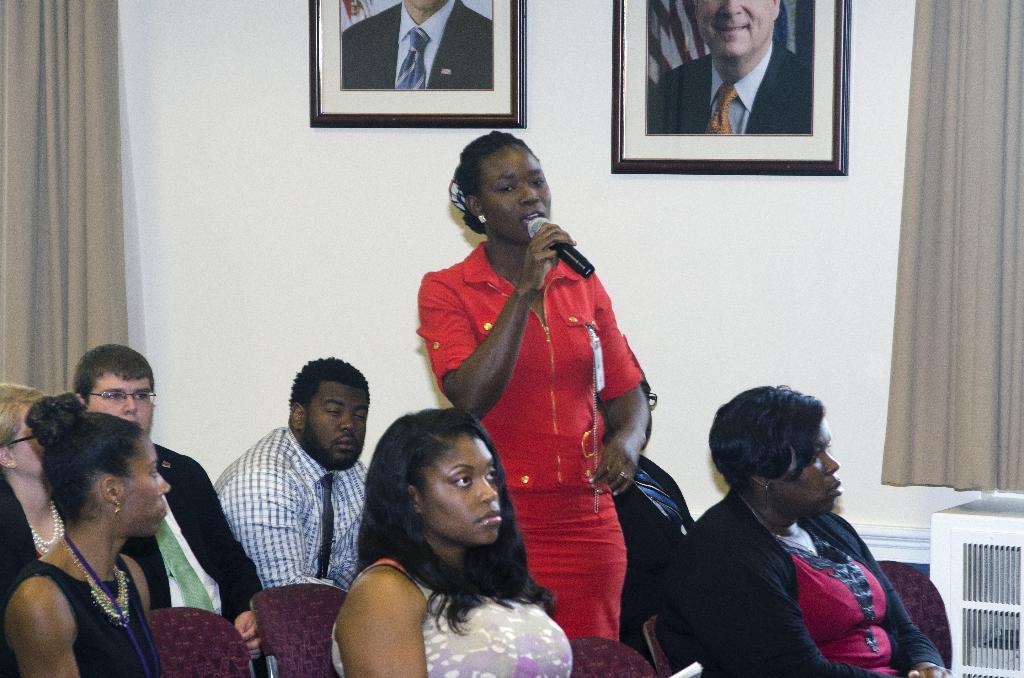Could you give a brief overview of what you see in this image? In this image we can see group of people sitting on chairs. One person is wearing a shirt and black tie. A women is wearing a red dress and holding a microphone in her hand is standing. In the background we can see curtains and photo frames on the wall. 